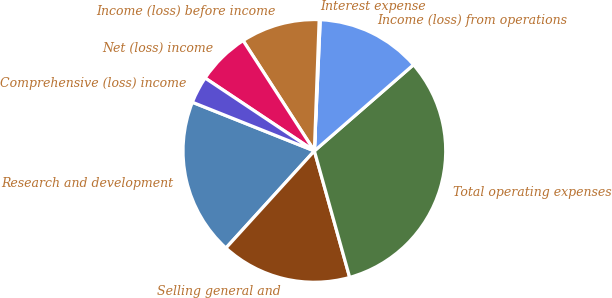Convert chart. <chart><loc_0><loc_0><loc_500><loc_500><pie_chart><fcel>Research and development<fcel>Selling general and<fcel>Total operating expenses<fcel>Income (loss) from operations<fcel>Interest expense<fcel>Income (loss) before income<fcel>Net (loss) income<fcel>Comprehensive (loss) income<nl><fcel>19.29%<fcel>16.09%<fcel>32.06%<fcel>12.9%<fcel>0.13%<fcel>9.71%<fcel>6.51%<fcel>3.32%<nl></chart> 